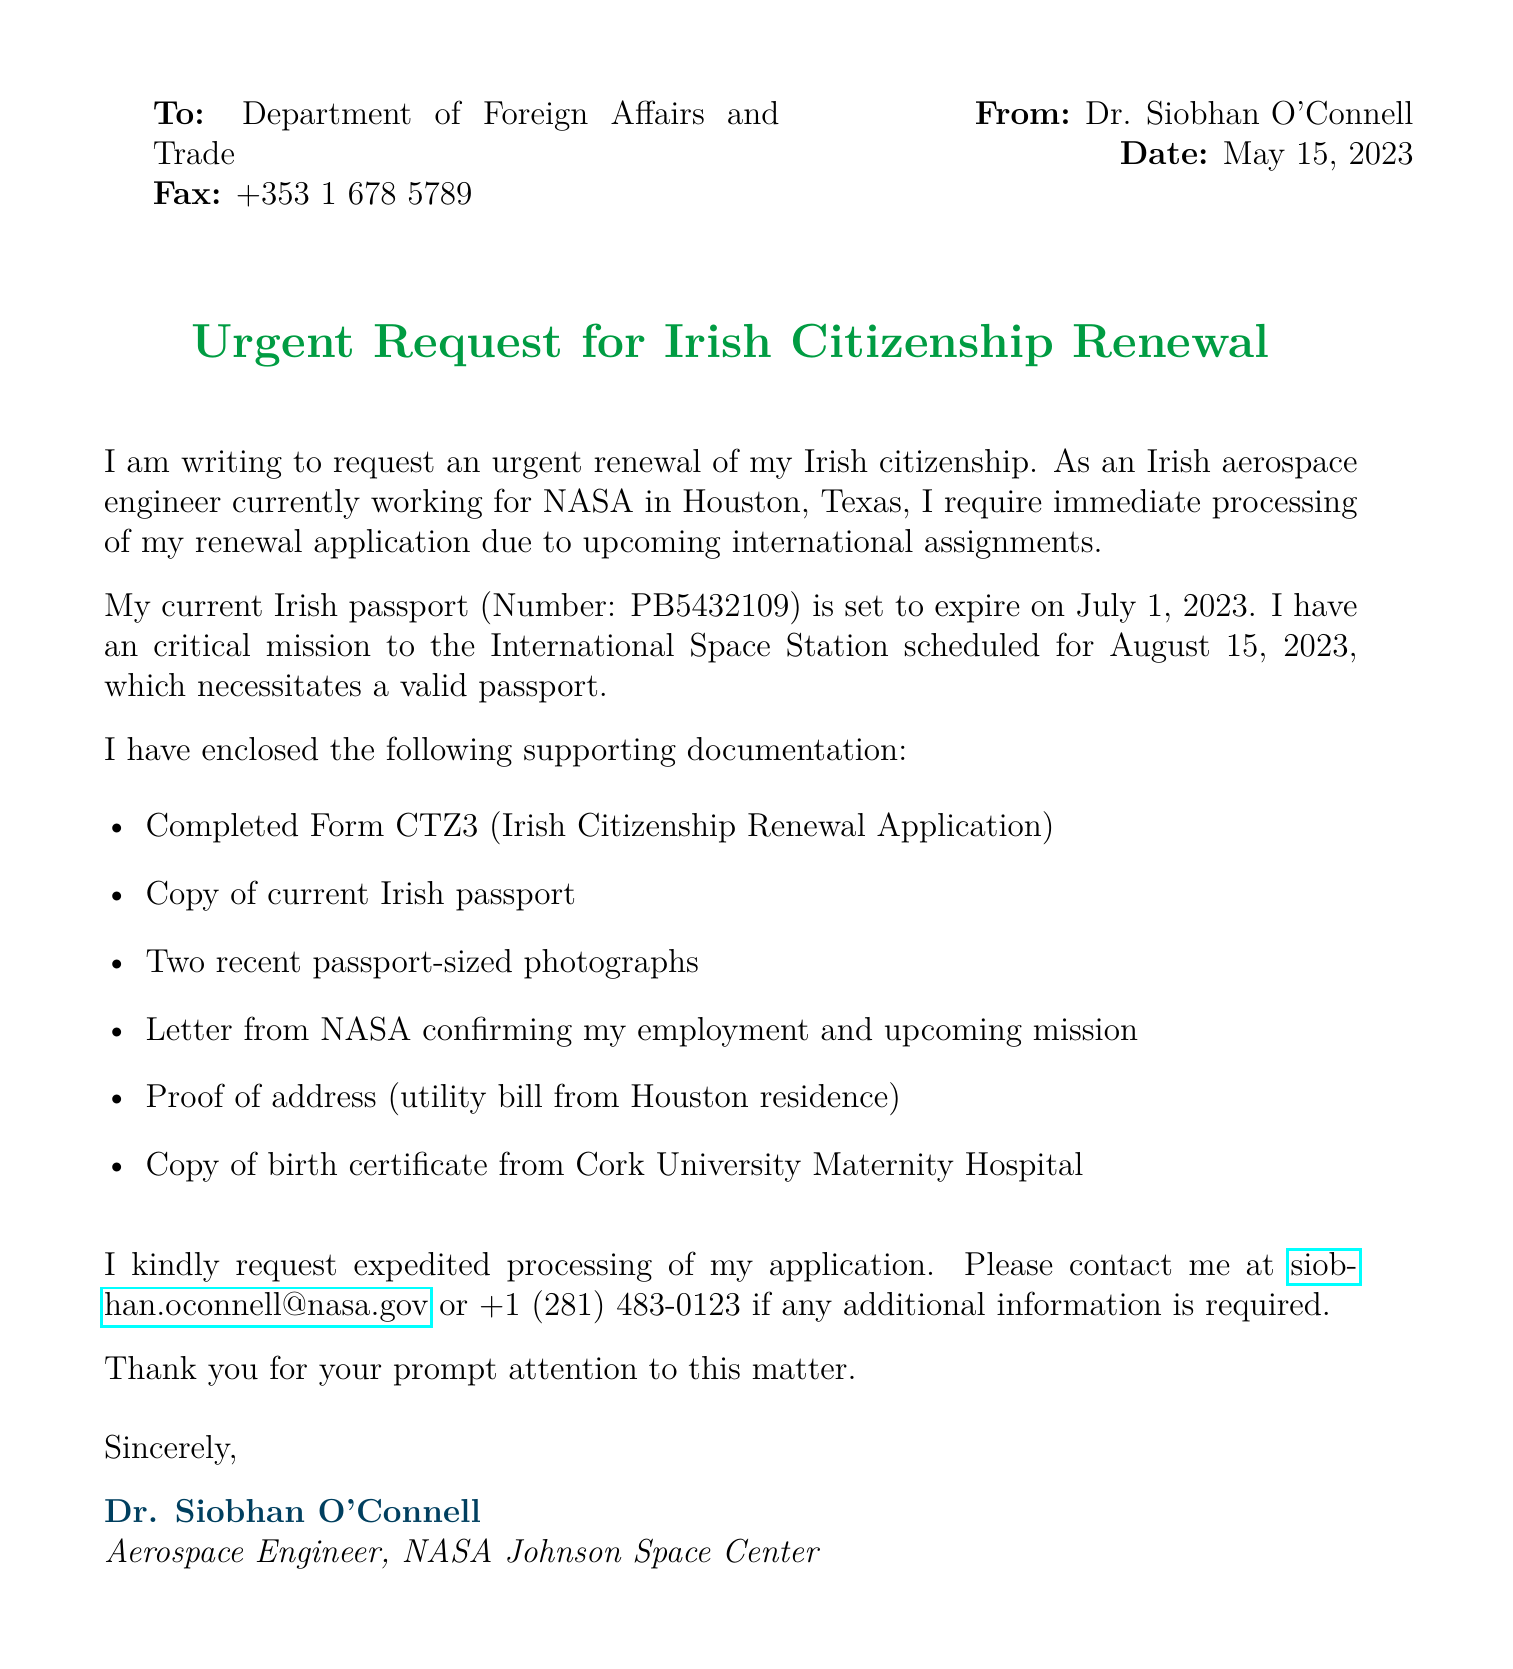What is the date of the fax? The date of the fax is indicated at the top right corner of the document.
Answer: May 15, 2023 Who is the fax from? The sender's name is provided in the "From" section of the document.
Answer: Dr. Siobhan O'Connell What is the purpose of the fax? The purpose is stated in the central title of the document.
Answer: Urgent Request for Irish Citizenship Renewal What is the current passport number? The current passport number is mentioned in the body of the fax.
Answer: PB5432109 When does the passport expire? The expiration date is clearly listed in the text.
Answer: July 1, 2023 What upcoming mission is mentioned? The specific mission is referred to in the context of the urgency of the request.
Answer: International Space Station What is the primary reason for the urgent request? The reason is due to the upcoming international assignments tied to the sender's profession.
Answer: Upcoming international assignments How many passport-sized photographs are enclosed? The number of photographs is stated in the list of supporting documentation.
Answer: Two What is included as proof of address? The document explicitly lists the item provided as proof of address.
Answer: Utility bill from Houston residence What is the contact email provided? The contact email is clearly written in the closing section of the fax.
Answer: siobhan.oconnell@nasa.gov 